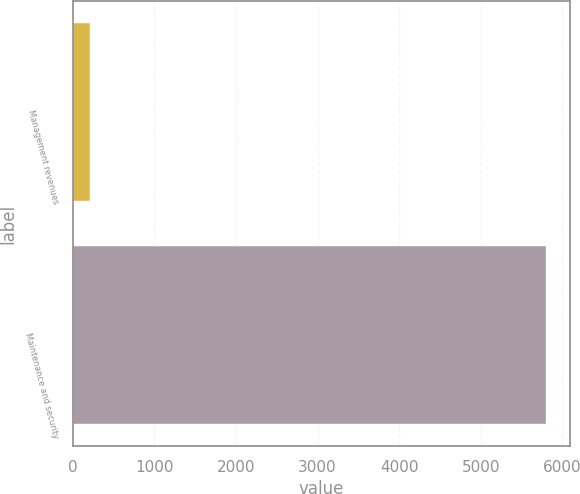Convert chart. <chart><loc_0><loc_0><loc_500><loc_500><bar_chart><fcel>Management revenues<fcel>Maintenance and security<nl><fcel>212<fcel>5805<nl></chart> 